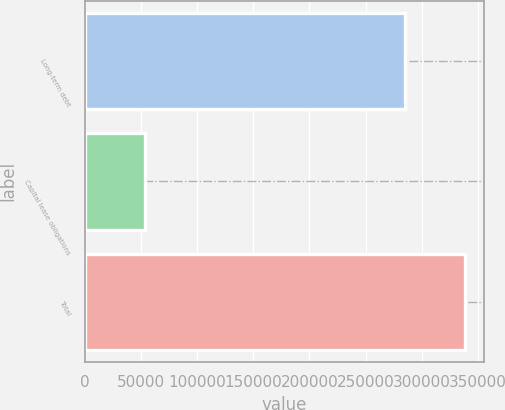Convert chart to OTSL. <chart><loc_0><loc_0><loc_500><loc_500><bar_chart><fcel>Long-term debt<fcel>Capital lease obligations<fcel>Total<nl><fcel>284822<fcel>53902<fcel>338724<nl></chart> 